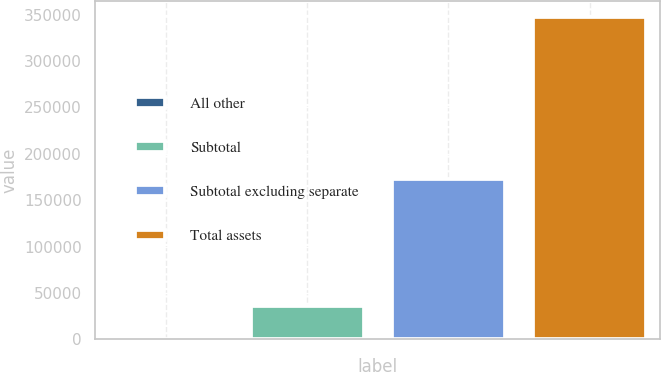<chart> <loc_0><loc_0><loc_500><loc_500><bar_chart><fcel>All other<fcel>Subtotal<fcel>Subtotal excluding separate<fcel>Total assets<nl><fcel>799<fcel>35461<fcel>173345<fcel>347419<nl></chart> 